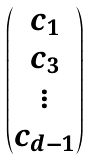<formula> <loc_0><loc_0><loc_500><loc_500>\begin{pmatrix} c _ { 1 } \\ c _ { 3 } \\ \vdots \\ c _ { d - 1 } \end{pmatrix}</formula> 